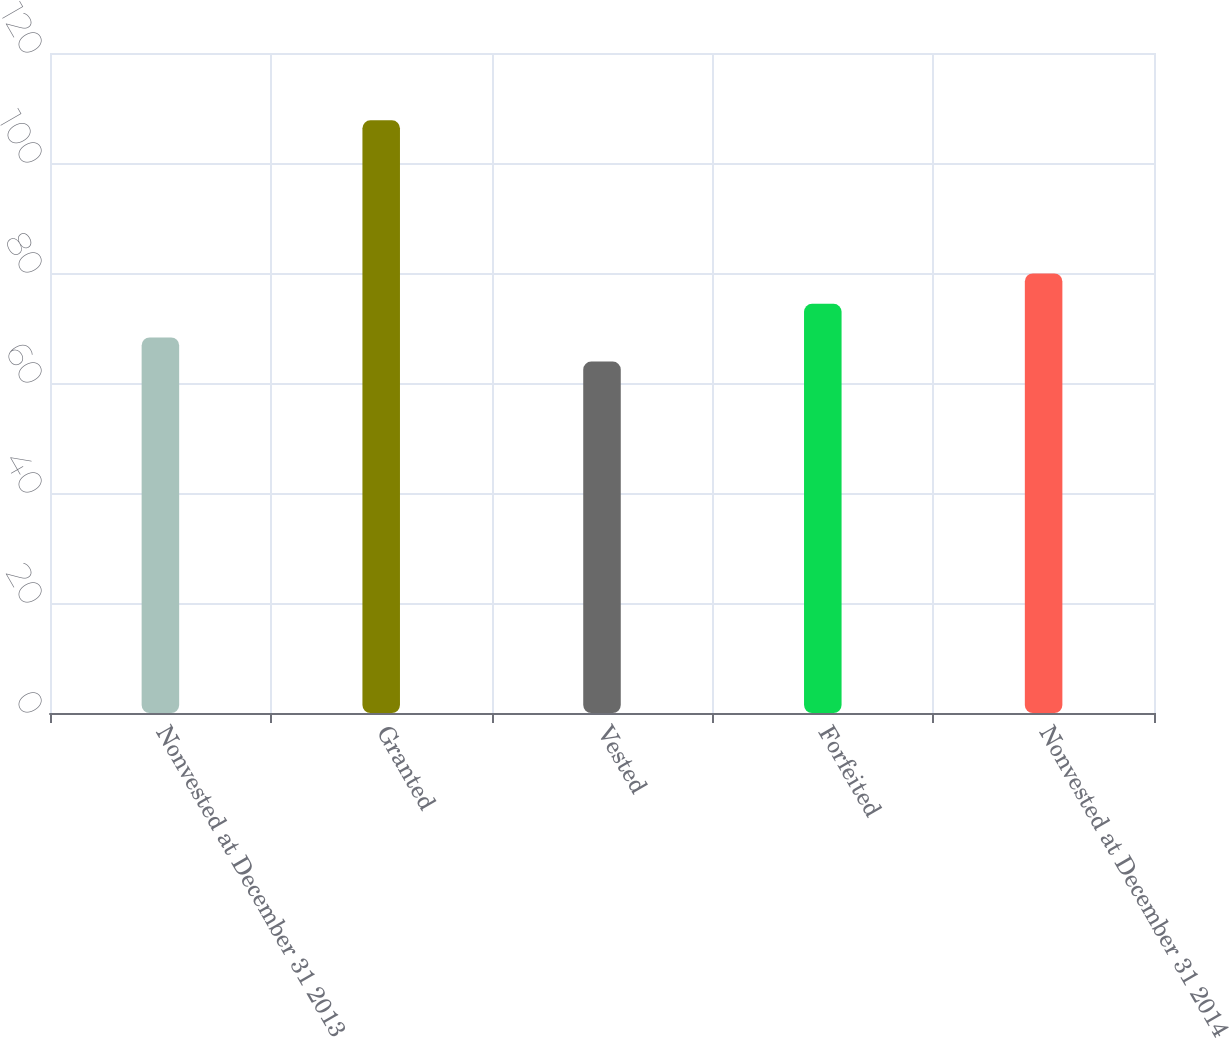<chart> <loc_0><loc_0><loc_500><loc_500><bar_chart><fcel>Nonvested at December 31 2013<fcel>Granted<fcel>Vested<fcel>Forfeited<fcel>Nonvested at December 31 2014<nl><fcel>68.28<fcel>107.76<fcel>63.89<fcel>74.39<fcel>79.92<nl></chart> 